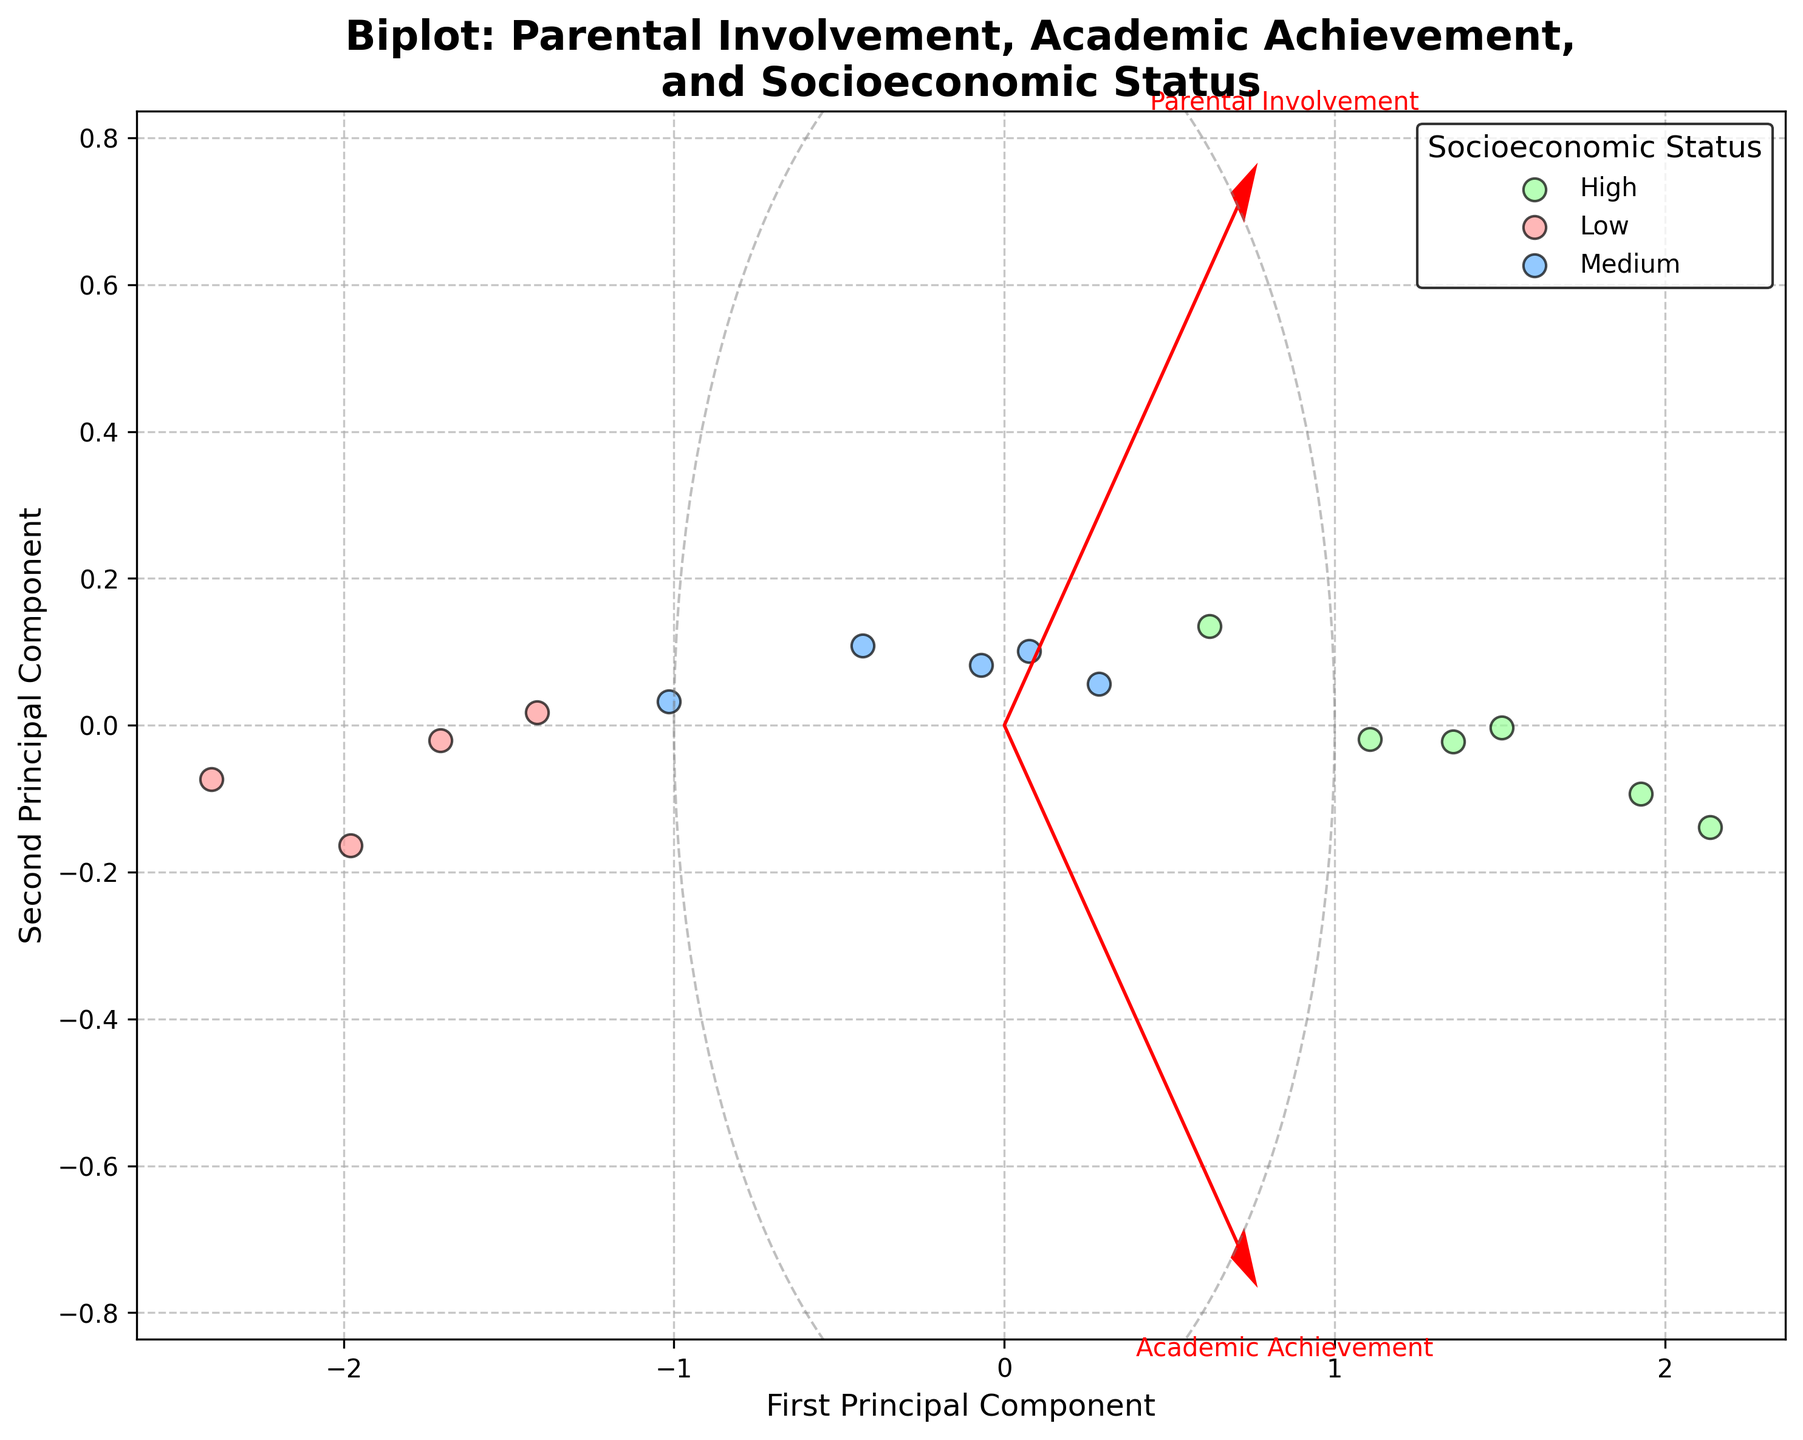How many categories of socioeconomic status are represented in the plot? The plot shows three different colors representing categories of socioeconomic status: Low, Medium, and High.
Answer: 3 What do the arrows represent in the biplot? The arrows indicate the direction and magnitude of the original variables (Parental Involvement and Academic Achievement) in the PCA-transformed space.
Answer: Original variables Which socioeconomic status has data points with the highest spread along the first principal component? By observing the scatter points along the first principal component (horizontal axis), the High socioeconomic status appears to have the widest spread.
Answer: High What is the title of the biplot? The title is clearly stated at the top of the plot. It reads "Biplot: Parental Involvement, Academic Achievement, and Socioeconomic Status."
Answer: Biplot: Parental Involvement, Academic Achievement, and Socioeconomic Status How is the second principal component represented in the plot? The second principal component is represented along the vertical axis of the plot.
Answer: Vertical axis In which principal component do you see greater variation for the 'Medium' socioeconomic status group? Observe the spread of the 'Medium' group's (blue points) along both principal components. The variation seems more pronounced along the first principal component (horizontal axis) than the second.
Answer: First principal component Which feature has a greater association with the first principal component? By looking at the length of the arrow projections on the first principal component, Parental Involvement shows a greater association as its arrow is more aligned with the horizontal axis.
Answer: Parental Involvement Does the 'Low' socioeconomic group generally show higher or lower academic achievement compared to 'High' socioeconomic group? The scatter points for 'Low' socioeconomic group are generally located closer to the lower end of the Academic Achievement arrow, indicating lower academic achievement compared to the 'High' group.
Answer: Lower Which socioeconomic status group shows points closest to the origin of the biplot? Observing the scatter, the 'Medium' (blue points) socioeconomic status group appears to have points closest to the center (origin) of the biplot.
Answer: Medium Are the variables 'Parental Involvement' and 'Academic Achievement' positively or negatively correlated? The arrows for 'Parental Involvement' and 'Academic Achievement' are pointing roughly in the same direction, indicating a positive correlation.
Answer: Positively correlated 